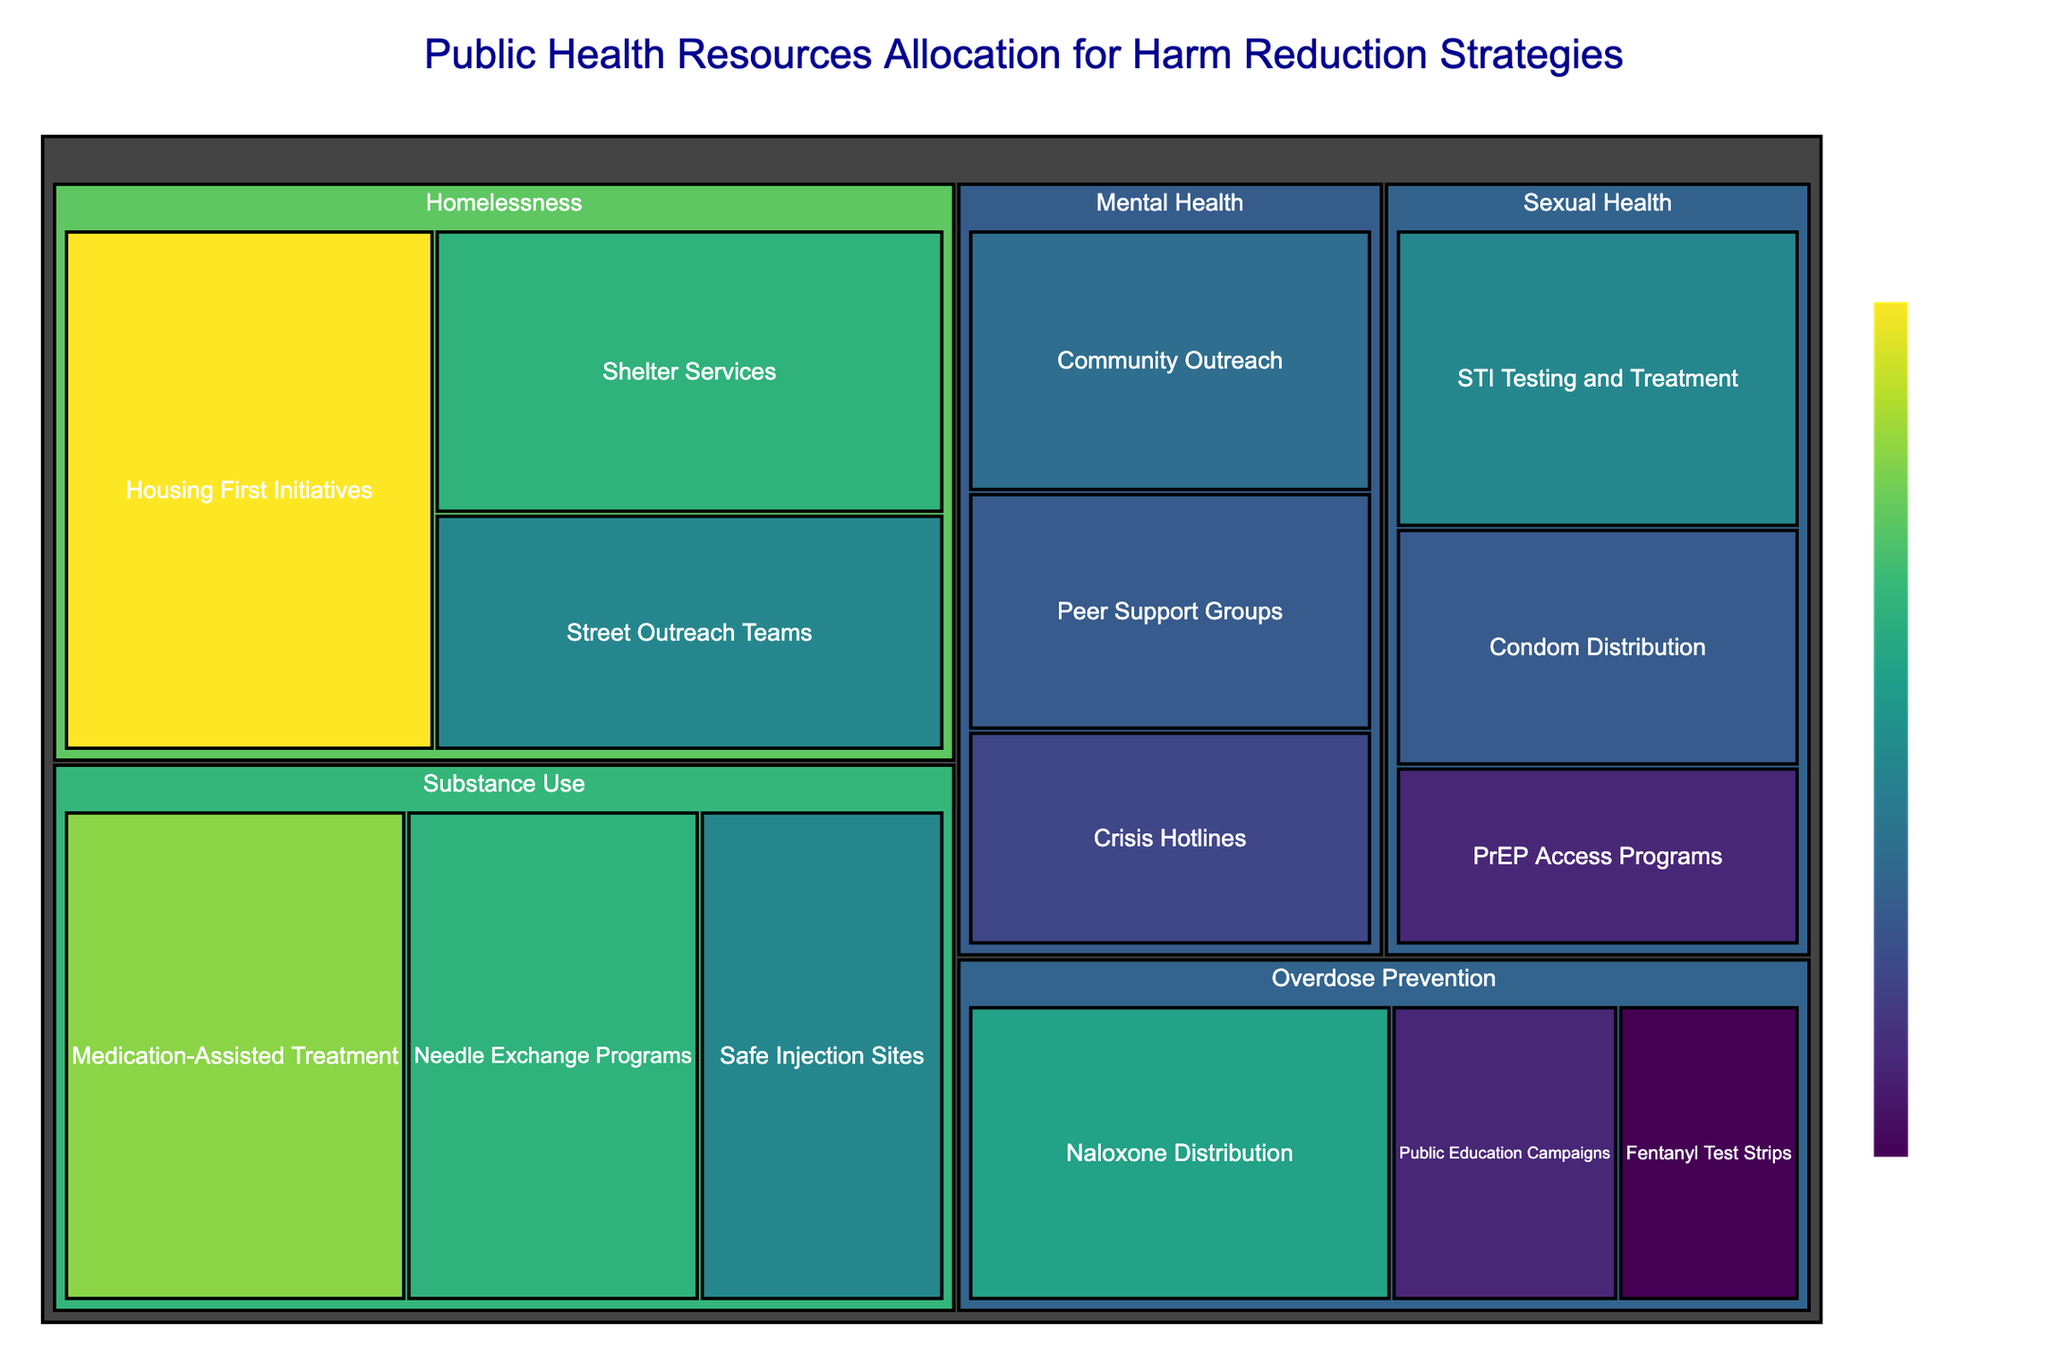What's the title of the plot? To find the title of the plot, we look at the top part of the figure where titles are commonly placed.
Answer: Public Health Resources Allocation for Harm Reduction Strategies How many subcategories are there under Substance Use? Identify and count all the subcategories listed under the Substance Use category in the treemap.
Answer: 3 Which subcategory under Homelessness has the highest resource allocation? Compare the values of all subcategories under Homelessness and find the one with the highest value.
Answer: Housing First Initiatives What's the total value allocated to Overdose Prevention? Sum all the values of the subcategories under the Overdose Prevention category. They are Naloxone Distribution (28), Fentanyl Test Strips (12), and Public Education Campaigns (15).
Answer: 55 Which category has the lowest overall resource allocation? Compare the total values of all resources allocated to each category by summing each subcategory's value within each category.
Answer: Sexual Health How does the allocation of resources to Medication-Assisted Treatment compare to Safe Injection Sites? Directly compare the values of Medication-Assisted Treatment (35) and Safe Injection Sites (25) within the Substance Use category.
Answer: Medication-Assisted Treatment has more resources What is the average resource allocation for Mental Health subcategories? Add the values of Crisis Hotlines (18), Community Outreach (22), and Peer Support Groups (20), then divide the sum by the number of subcategories (3).
Answer: 20 Is Needle Exchange Programs' allocation higher or lower than Naloxone Distribution? Compare the values of Needle Exchange Programs (30) and Naloxone Distribution (28).
Answer: Higher Which category has the most diversity in subcategories listed? Count the number of subcategories within each category and identify which has the most subcategories.
Answer: Homelessness, with 3 subcategories Are there any subcategories with equal resource allocation values? Scan the treemap for subcategories with identical values. Both Peer Support Groups and Condom Distribution are allocated 20 units each.
Answer: Yes 